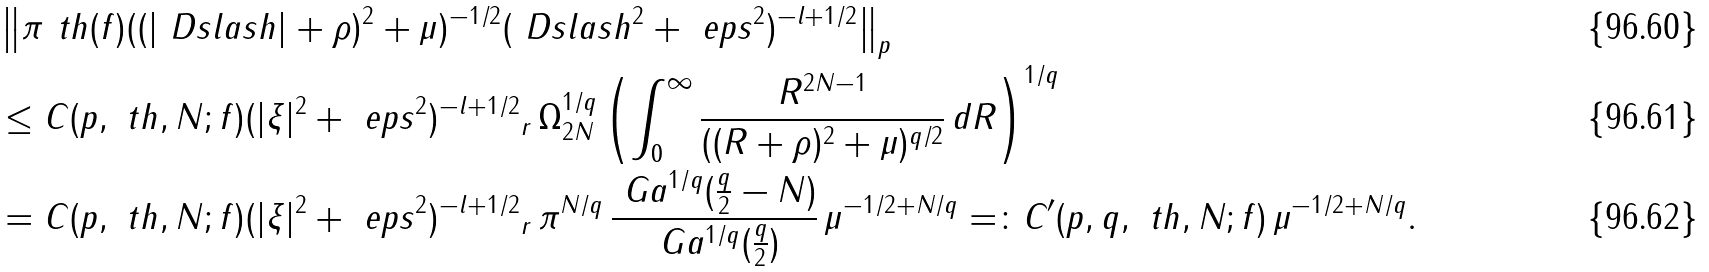<formula> <loc_0><loc_0><loc_500><loc_500>& \left \| \pi ^ { \ } t h ( f ) ( ( | \ D s l a s h | + \rho ) ^ { 2 } + \mu ) ^ { - 1 / 2 } ( \ D s l a s h ^ { 2 } + \ e p s ^ { 2 } ) ^ { - l + 1 / 2 } \right \| _ { p } \\ & \leq C ( p , \ t h , N ; f ) \| ( | \xi | ^ { 2 } + \ e p s ^ { 2 } ) ^ { - l + 1 / 2 } \| _ { r } \, \Omega _ { 2 N } ^ { 1 / q } \left ( \int _ { 0 } ^ { \infty } \frac { R ^ { 2 N - 1 } } { ( ( R + \rho ) ^ { 2 } + \mu ) ^ { q / 2 } } \, d R \right ) ^ { 1 / q } \\ & = C ( p , \ t h , N ; f ) \| ( | \xi | ^ { 2 } + \ e p s ^ { 2 } ) ^ { - l + 1 / 2 } \| _ { r } \, \pi ^ { N / q } \, \frac { \ G a ^ { 1 / q } ( \frac { q } { 2 } - N ) } { \ G a ^ { 1 / q } ( \frac { q } { 2 } ) } \, \mu ^ { - 1 / 2 + N / q } = \colon C ^ { \prime } ( p , q , \ t h , N ; f ) \, \mu ^ { - 1 / 2 + N / q } .</formula> 